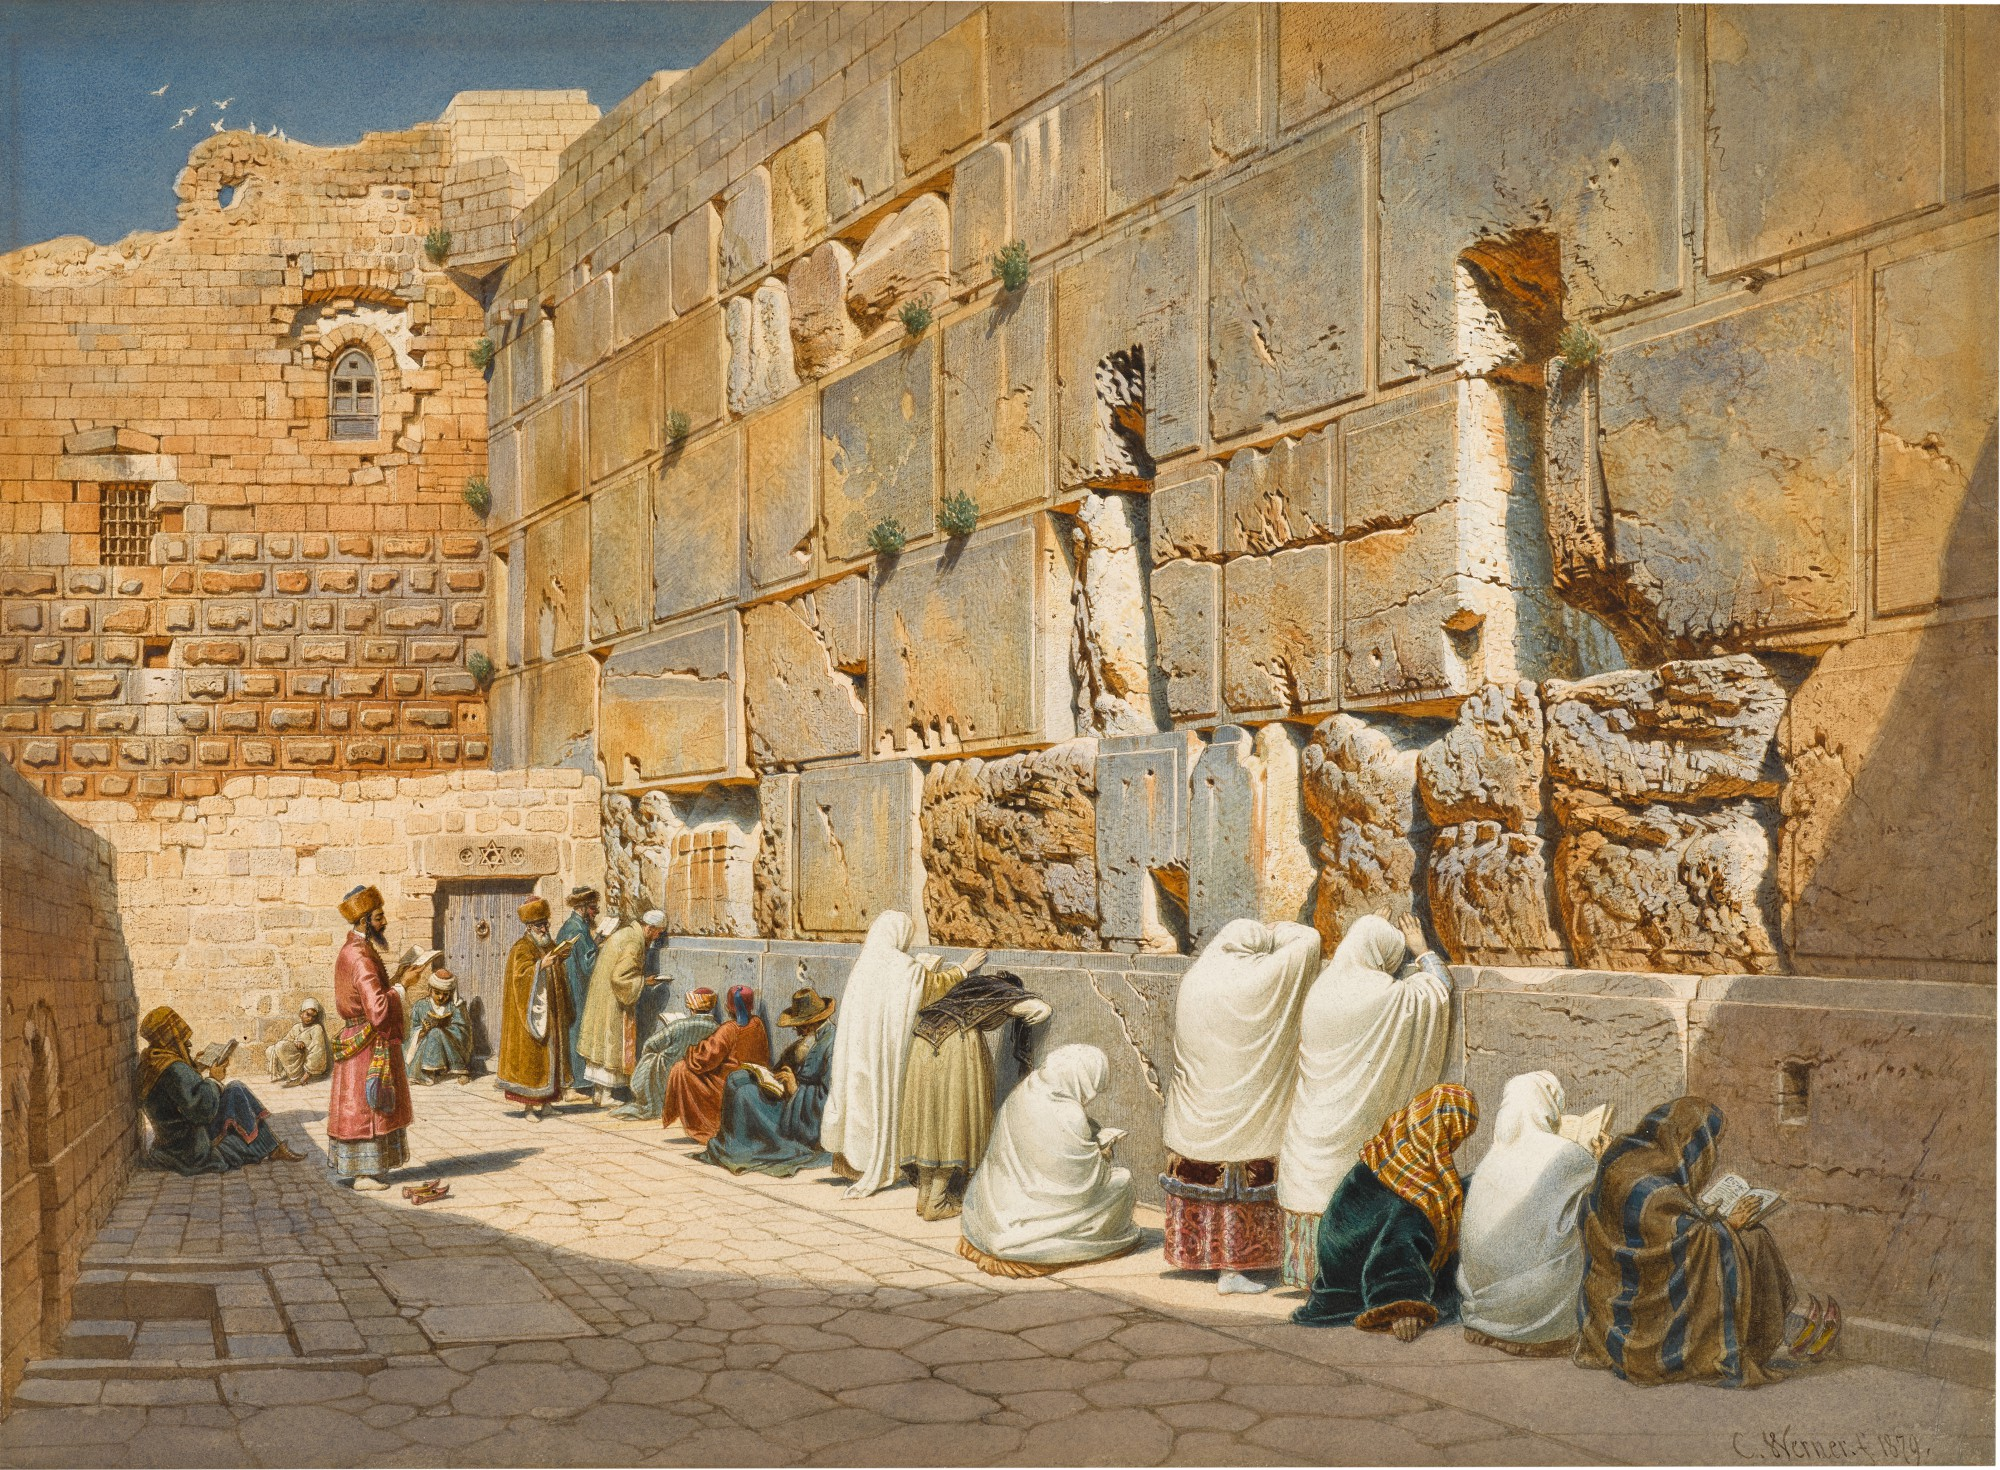What does the presence of birds flying over the wall signify in this image? The birds flying above the Wailing Wall introduce a symbolic layer to the image, representing freedom and peace. In many cultures, birds are considered as carriers of hope and spiritual messengers. Their presence above such a historically and religiously charged site might suggest the overarching theme of transcendence and the human yearning for connection with the divine. This element subtly contrasts the grounded, solemn activities at the wall, providing a hopeful balance to the scene. 